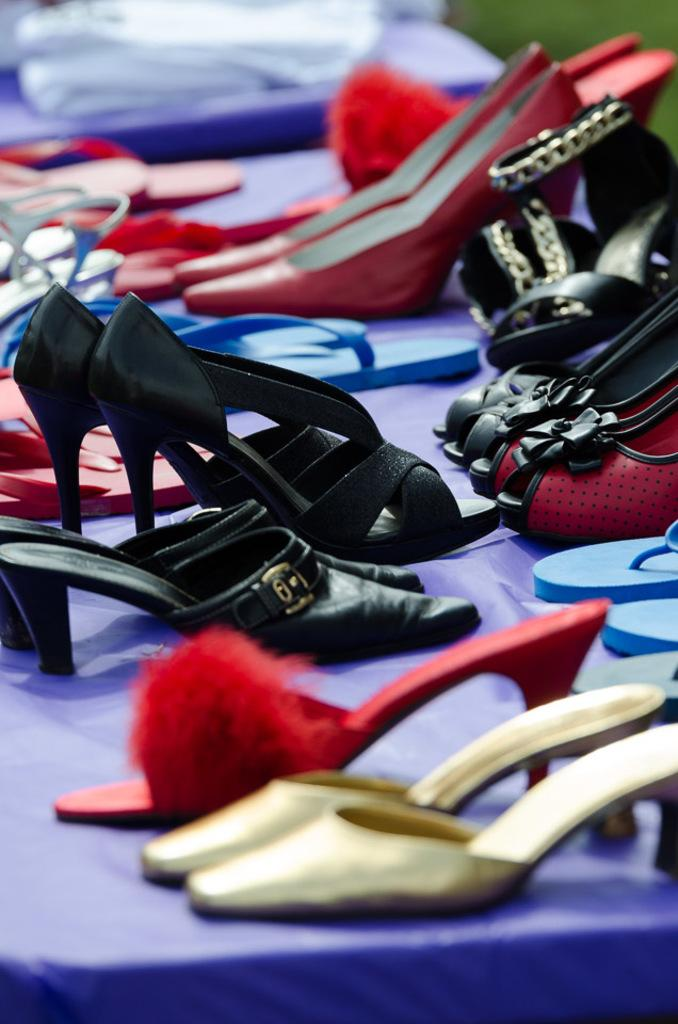What is located in the middle of the image? There is footwear in the middle of the image. Can you describe the footwear in the image? Unfortunately, the facts provided do not give any details about the footwear. Is there anything else in the image besides the footwear? The facts provided do not mention any other objects or elements in the image. What type of tray is visible in the image? There is no tray present in the image; it only features footwear. What angle is the footwear displayed at in the image? The facts provided do not give any information about the angle or orientation of the footwear in the image. 